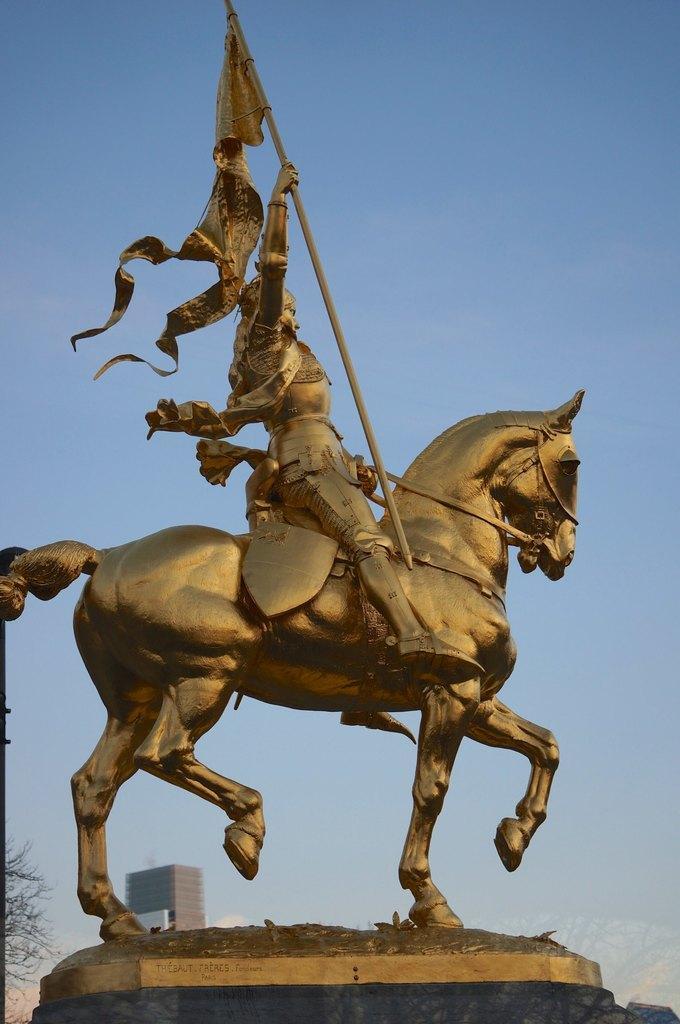Describe this image in one or two sentences. In the picture we can see the sculpture of a horse with a person sitting and holding a pole with a flag and behind it we can see a building and the sky. 